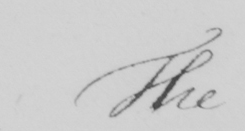Please transcribe the handwritten text in this image. The 